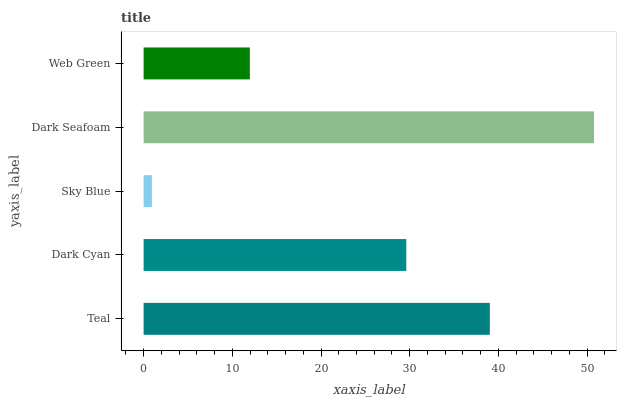Is Sky Blue the minimum?
Answer yes or no. Yes. Is Dark Seafoam the maximum?
Answer yes or no. Yes. Is Dark Cyan the minimum?
Answer yes or no. No. Is Dark Cyan the maximum?
Answer yes or no. No. Is Teal greater than Dark Cyan?
Answer yes or no. Yes. Is Dark Cyan less than Teal?
Answer yes or no. Yes. Is Dark Cyan greater than Teal?
Answer yes or no. No. Is Teal less than Dark Cyan?
Answer yes or no. No. Is Dark Cyan the high median?
Answer yes or no. Yes. Is Dark Cyan the low median?
Answer yes or no. Yes. Is Dark Seafoam the high median?
Answer yes or no. No. Is Web Green the low median?
Answer yes or no. No. 